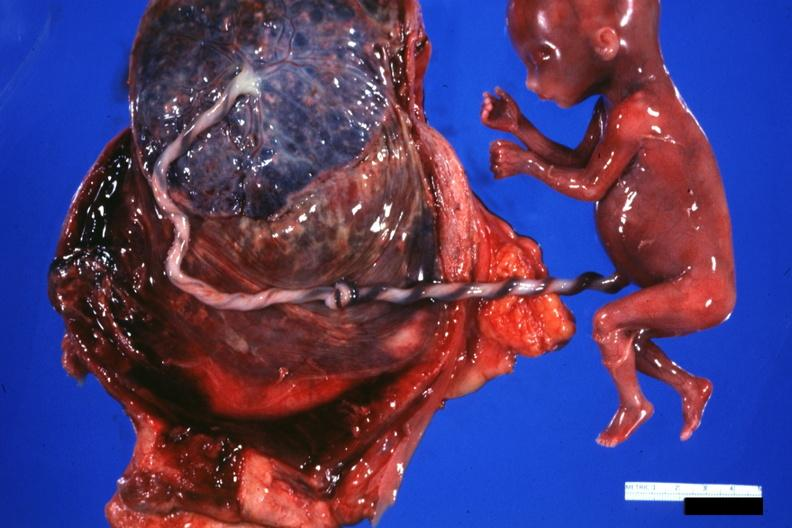what does this image show?
Answer the question using a single word or phrase. Fetus cord with knot and placenta 